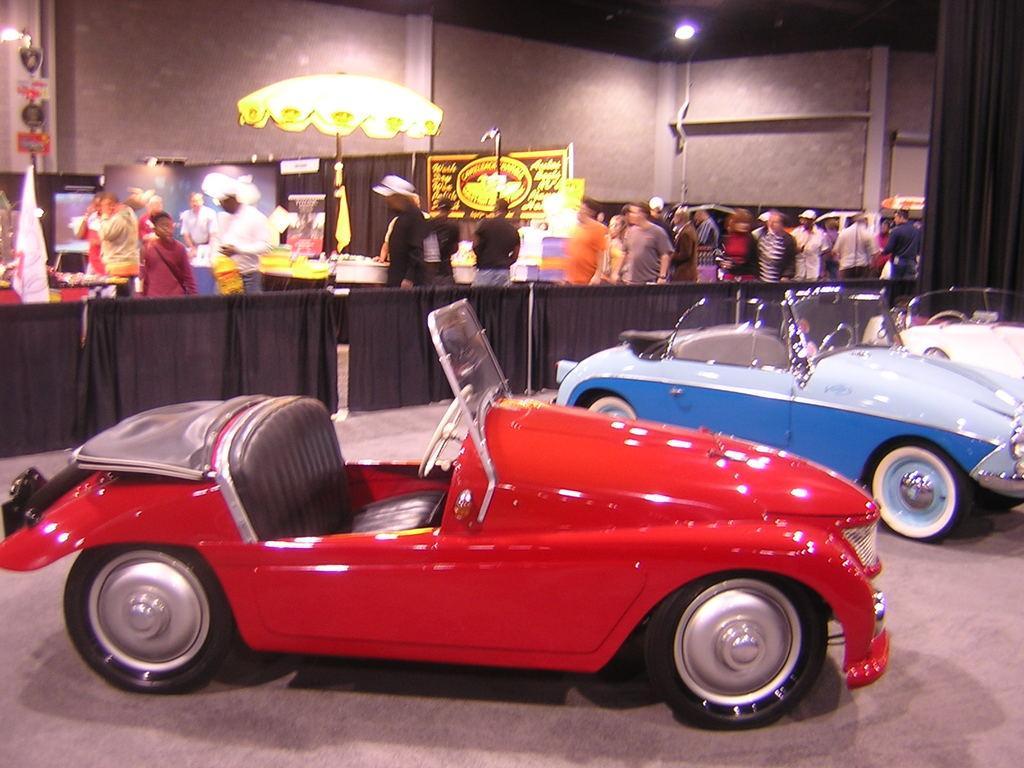In one or two sentences, can you explain what this image depicts? In this image there are vehicles. In the background there are curtains, parasol, boards and lights. We can see people standing and there is a wall. 